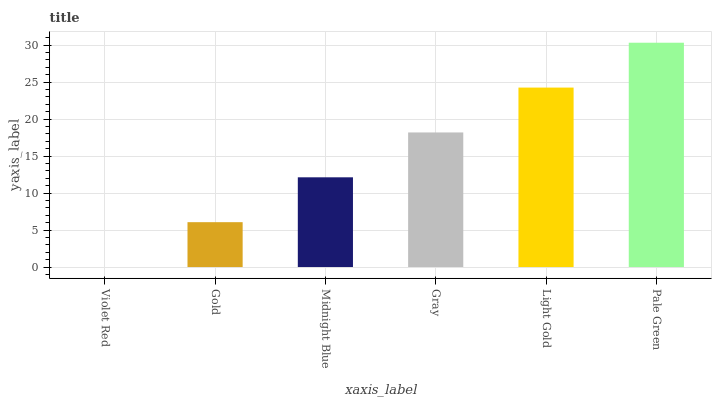Is Violet Red the minimum?
Answer yes or no. Yes. Is Pale Green the maximum?
Answer yes or no. Yes. Is Gold the minimum?
Answer yes or no. No. Is Gold the maximum?
Answer yes or no. No. Is Gold greater than Violet Red?
Answer yes or no. Yes. Is Violet Red less than Gold?
Answer yes or no. Yes. Is Violet Red greater than Gold?
Answer yes or no. No. Is Gold less than Violet Red?
Answer yes or no. No. Is Gray the high median?
Answer yes or no. Yes. Is Midnight Blue the low median?
Answer yes or no. Yes. Is Pale Green the high median?
Answer yes or no. No. Is Pale Green the low median?
Answer yes or no. No. 